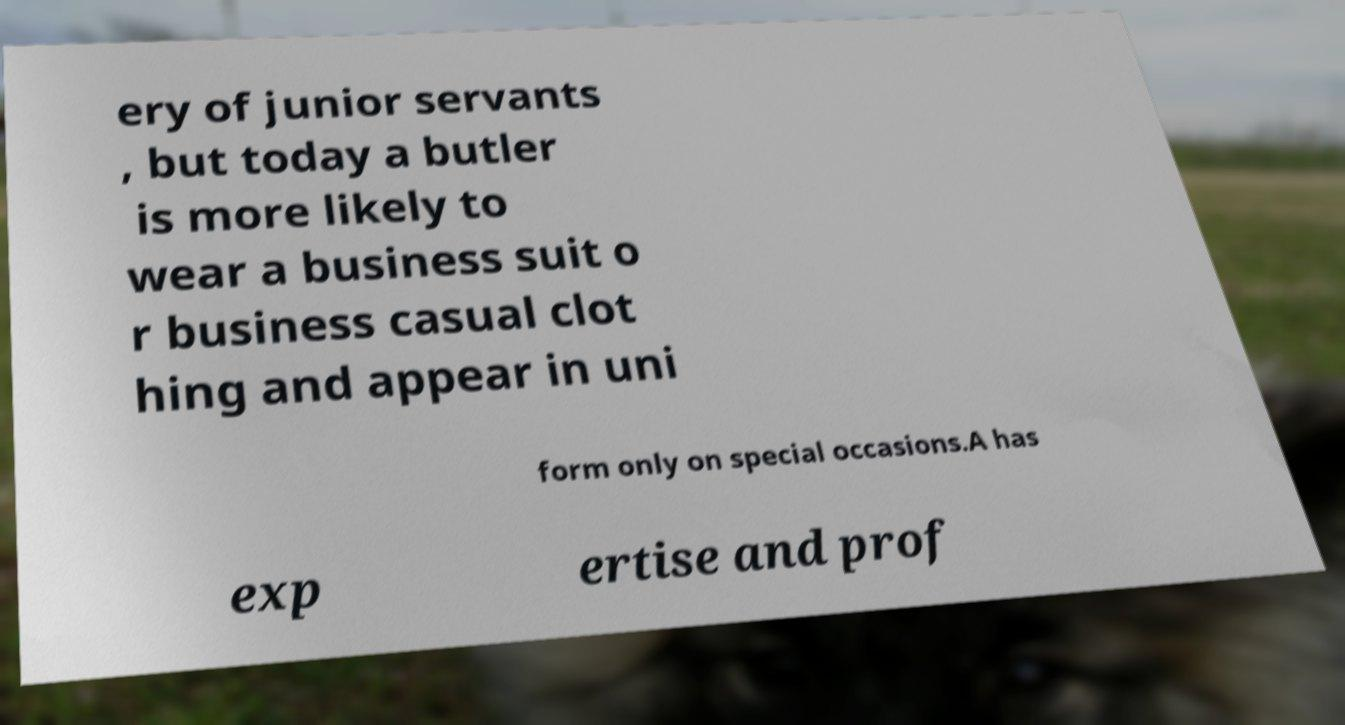Could you extract and type out the text from this image? ery of junior servants , but today a butler is more likely to wear a business suit o r business casual clot hing and appear in uni form only on special occasions.A has exp ertise and prof 